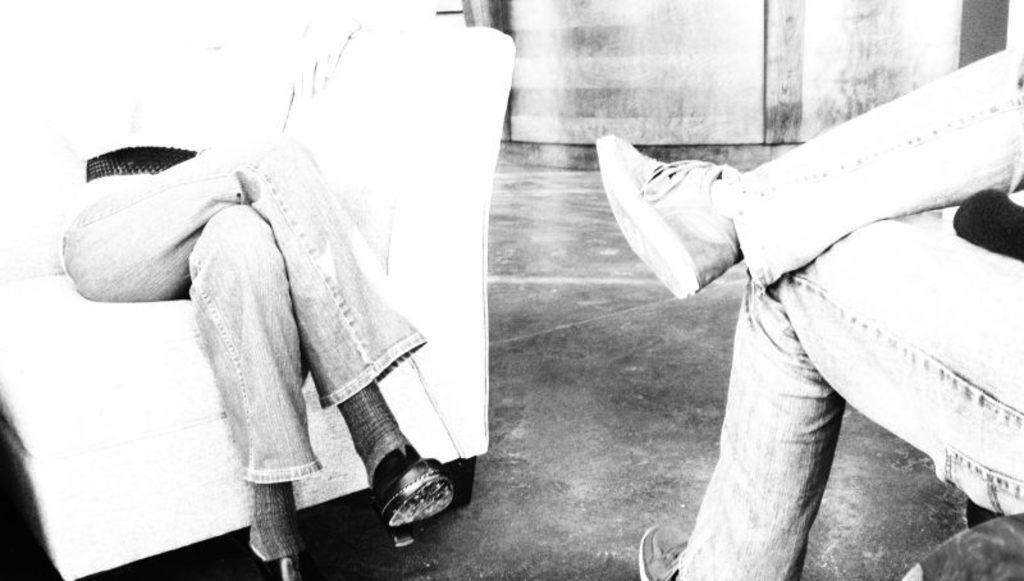What is the color scheme of the image? The image is black and white. How many people are in the image? There are two people in the image. What are the people doing in the image? The people are sitting on chairs. What else can be seen in the image besides the people? There are other things visible behind the people. How many snakes are slithering around the people in the image? There are no snakes present in the image. What message of hope can be seen in the image? The image does not convey any specific message of hope, as it is a simple black and white image of two people sitting on chairs. 